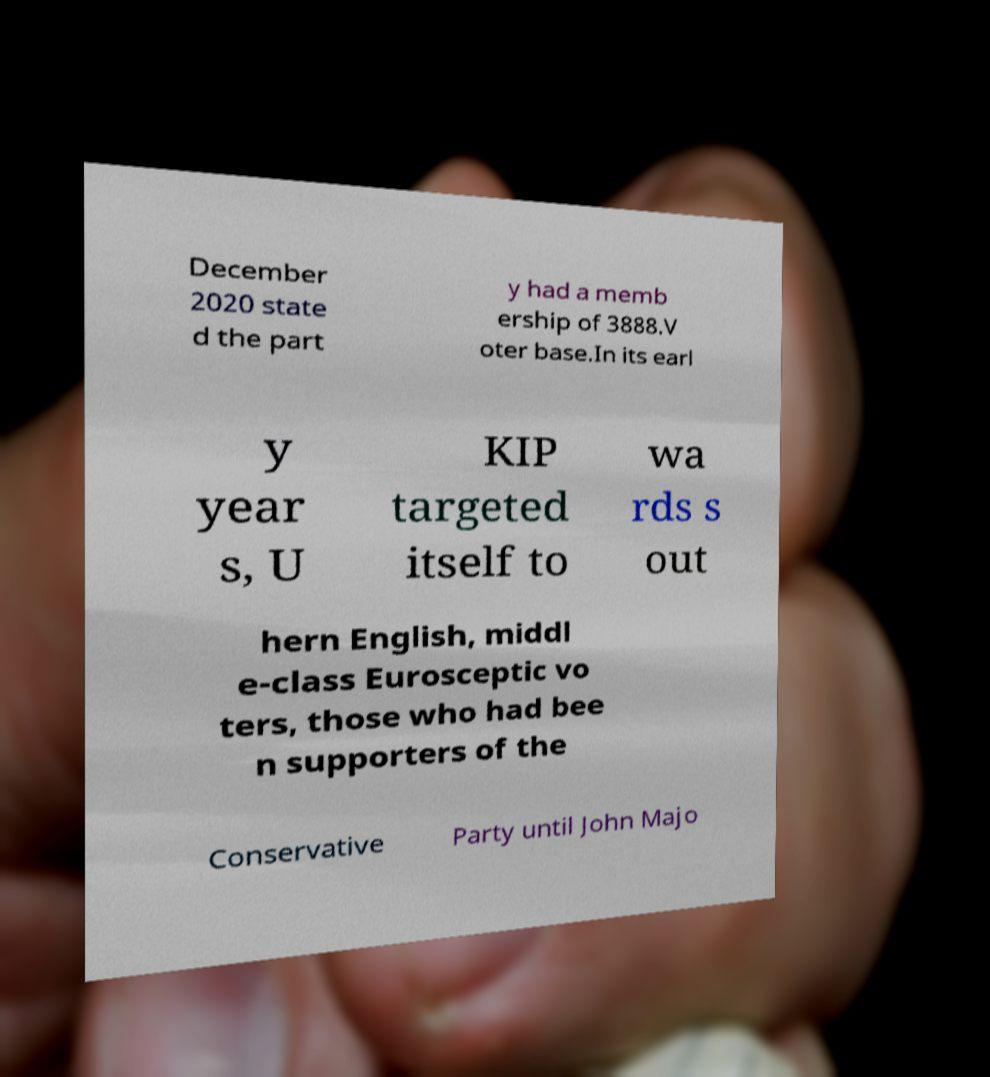Can you read and provide the text displayed in the image?This photo seems to have some interesting text. Can you extract and type it out for me? December 2020 state d the part y had a memb ership of 3888.V oter base.In its earl y year s, U KIP targeted itself to wa rds s out hern English, middl e-class Eurosceptic vo ters, those who had bee n supporters of the Conservative Party until John Majo 